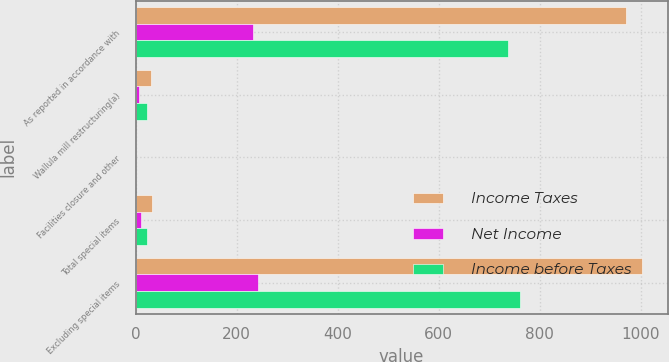Convert chart. <chart><loc_0><loc_0><loc_500><loc_500><stacked_bar_chart><ecel><fcel>As reported in accordance with<fcel>Wallula mill restructuring(a)<fcel>Facilities closure and other<fcel>Total special items<fcel>Excluding special items<nl><fcel>Income Taxes<fcel>970.5<fcel>30<fcel>1.8<fcel>32.5<fcel>1003<nl><fcel>Net Income<fcel>232.5<fcel>7.5<fcel>0.5<fcel>10.1<fcel>242.6<nl><fcel>Income before Taxes<fcel>738<fcel>22.5<fcel>1.3<fcel>22.4<fcel>760.4<nl></chart> 